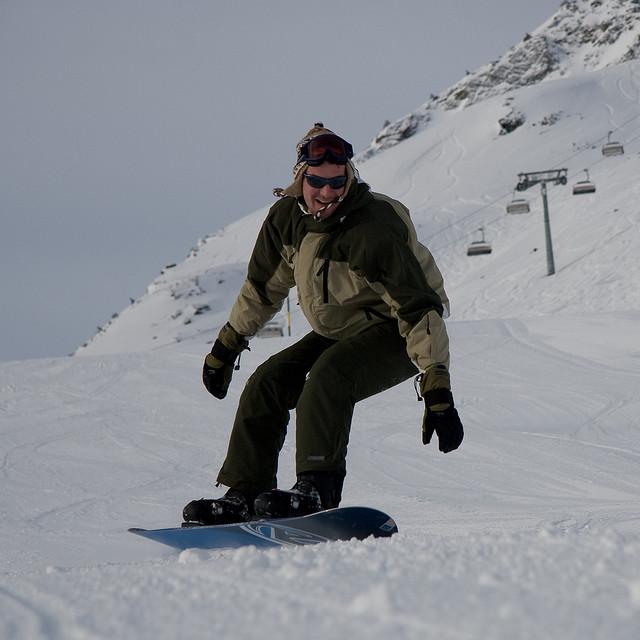How many ski lifts can you see?
Concise answer only. 4. What is on the snowboarders head?
Be succinct. Hat. Is the man snowboarding?
Keep it brief. Yes. 